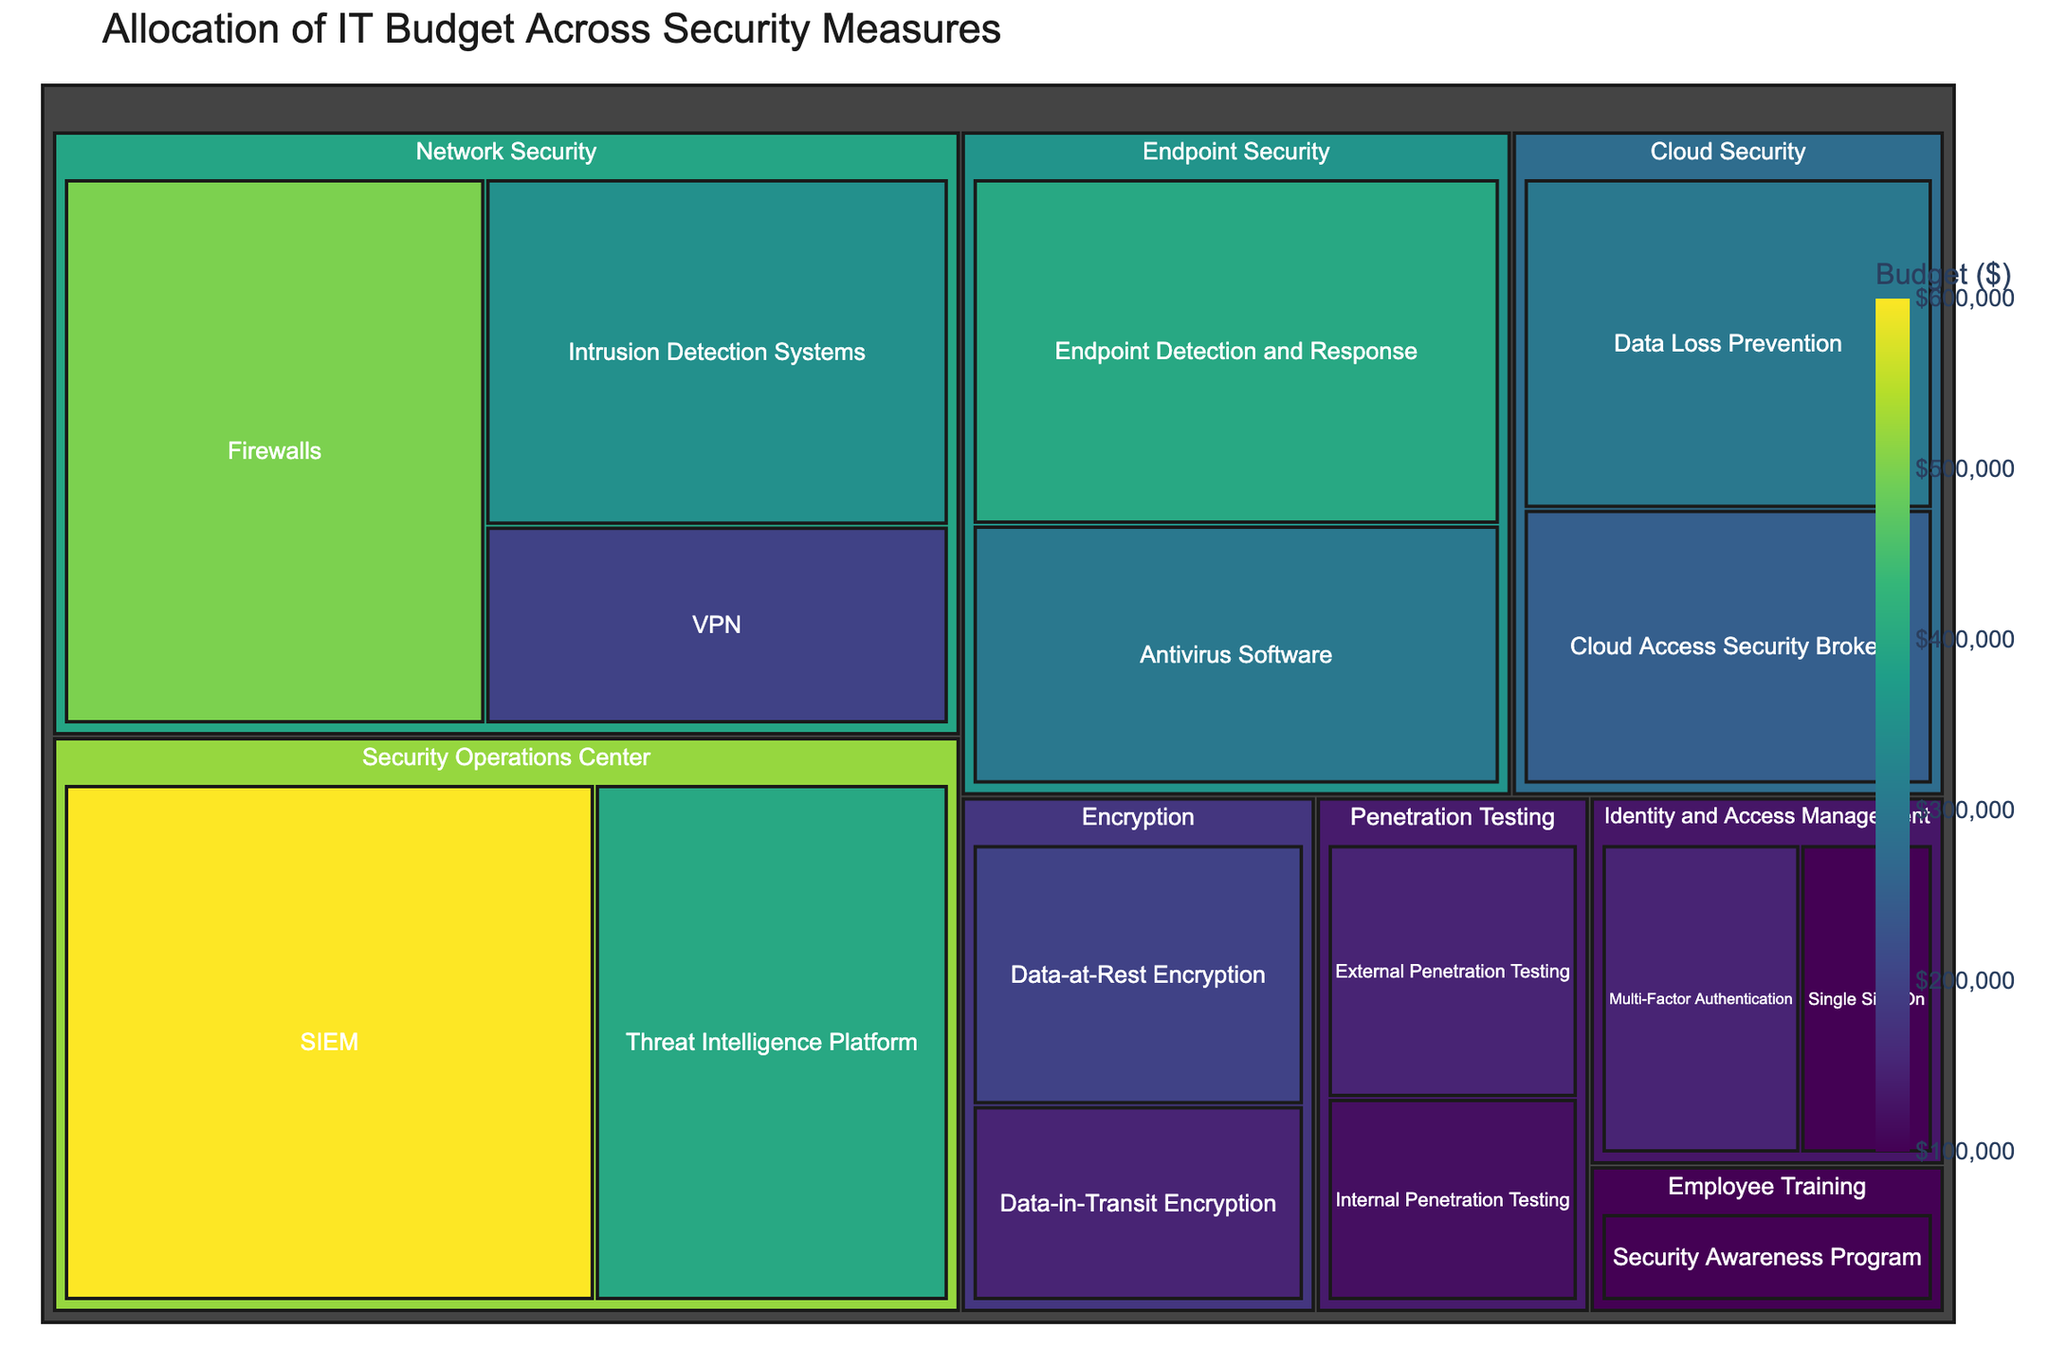What's the title of the figure? The title is prominently displayed at the top of the figure and provides a summary of what the treemap represents. The title will likely encapsulate the main theme of the data being visualized.
Answer: Allocation of IT Budget Across Security Measures Which category has the highest budget allocation? By observing the largest block in the treemap, we can determine the category with the highest budget allocation. The larger the block, the greater the budget. The Network Security block spans a large area.
Answer: Network Security What subcategory within 'Security Operations Center' has the higher budget? By looking closely at the two subcategories within 'Security Operations Center' in the treemap, we compare the sizes of their blocks. The subcategory with the larger block size will have the higher budget.
Answer: SIEM How much budget is allocated to 'Cloud Security' in total? We need to sum up the budgets of the subcategories under 'Cloud Security'. Specifically, add the budget for 'Cloud Access Security Broker' and 'Data Loss Prevention'. This is $250,000 + $300,000.
Answer: $550,000 Compare the budget allocation between 'Endpoint Security' and 'Encryption'. Which one is higher, and by how much? Compute the total budget for each category. 'Endpoint Security' has a total of $700,000 (Antivirus Software + Endpoint Detection and Response). 'Encryption' has a total of $350,000 (Data-at-Rest Encryption + Data-in-Transit Encryption). Subtract the smaller total from the larger.
Answer: Endpoint Security is higher by $350,000 What is the combined budget for 'Penetration Testing' and 'Employee Training'? To find the combined budget, add the budget amounts allocated to 'Penetration Testing' (External and Internal Penetration Testing) and 'Employee Training' (Security Awareness Program). This is $150,000 + $120,000 + $100,000.
Answer: $370,000 What's the largest single subcategory allocation, and which category does it belong to? Look for the largest single block within the treemap. This block represents the subcategory with the highest budget. The subcategory 'SIEM' within 'Security Operations Center' stands out.
Answer: SIEM with $600,000 Which subcategory has the smallest allocation, and how much is it? Identify the smallest block in the treemap, which represents the subcategory with the smallest budget. ‘Single Sign-On’ under 'Identity and Access Management' is the smallest.
Answer: Single Sign-On with $100,000 How does the budget for 'Intrusion Detection Systems' compare to 'Endpoint Detection and Response'? Compare the sizes of the blocks for 'Intrusion Detection Systems' and 'Endpoint Detection and Response'. Note their budget values and decide which is higher. 'Endpoint Detection and Response' has a higher budget.
Answer: Endpoint Detection and Response is higher by $50,000 